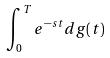<formula> <loc_0><loc_0><loc_500><loc_500>\int _ { 0 } ^ { T } e ^ { - s t } d g ( t )</formula> 